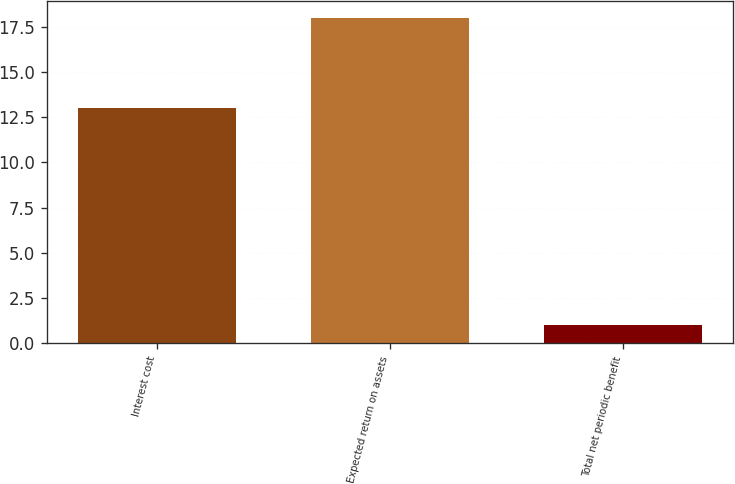Convert chart. <chart><loc_0><loc_0><loc_500><loc_500><bar_chart><fcel>Interest cost<fcel>Expected return on assets<fcel>Total net periodic benefit<nl><fcel>13<fcel>18<fcel>1<nl></chart> 